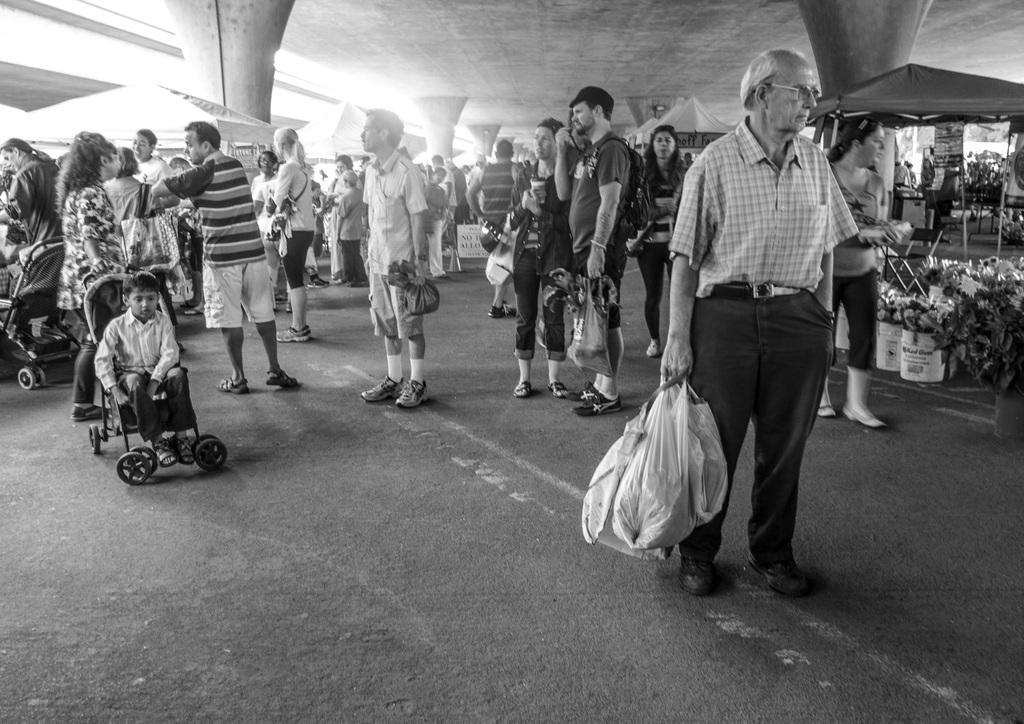What are the people in the image doing under the roof? The people in the image are standing under a roof. What are the people holding in their hands? The people are holding bags. What additional structures can be seen in the image? There are tents visible in the image. What color is the hydrant located near the tents in the image? There is no hydrant present in the image. What caused the people to gather under the roof in the image? The facts provided do not give any information about the reason for the people gathering under the roof. 